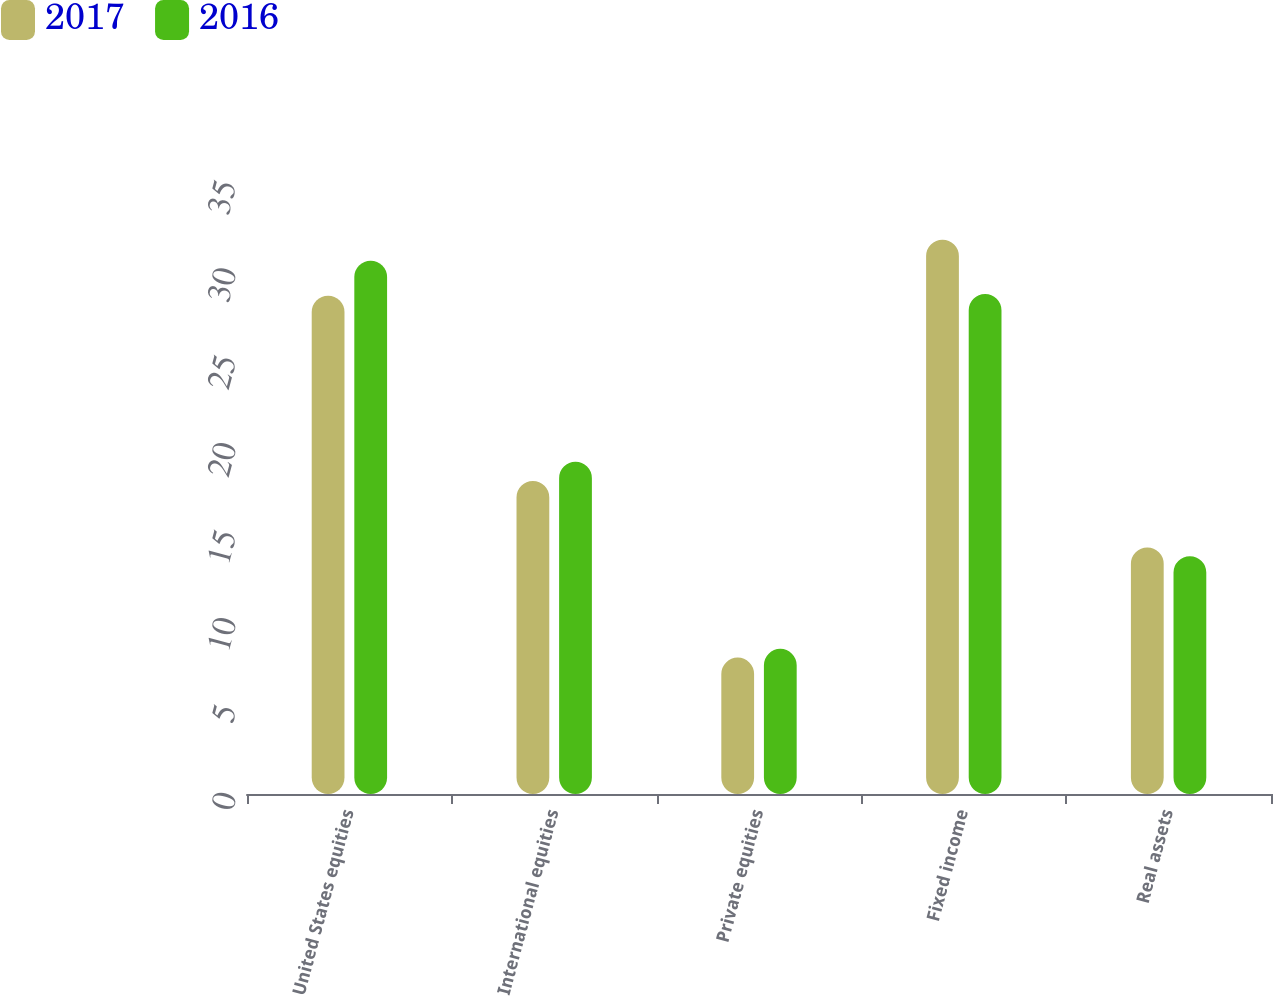<chart> <loc_0><loc_0><loc_500><loc_500><stacked_bar_chart><ecel><fcel>United States equities<fcel>International equities<fcel>Private equities<fcel>Fixed income<fcel>Real assets<nl><fcel>2017<fcel>28.5<fcel>17.9<fcel>7.8<fcel>31.7<fcel>14.1<nl><fcel>2016<fcel>30.5<fcel>19<fcel>8.3<fcel>28.6<fcel>13.6<nl></chart> 